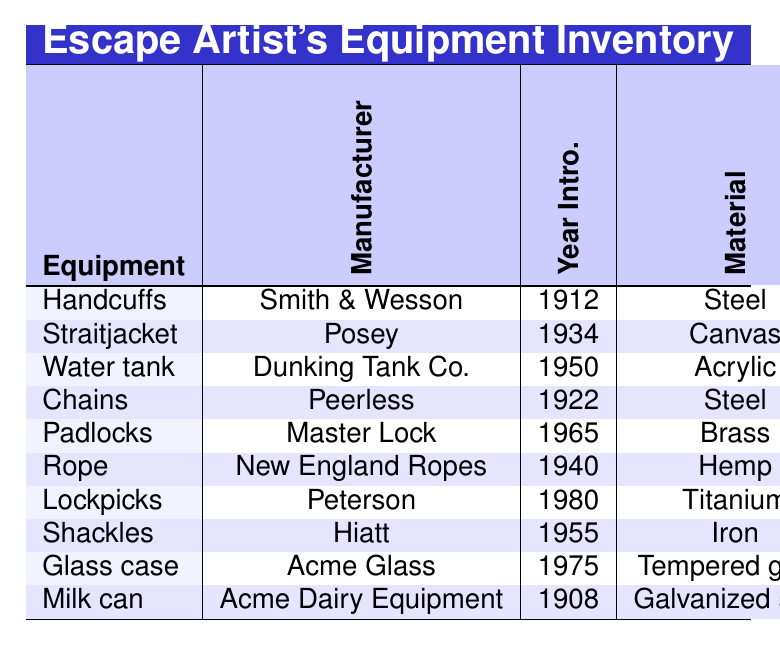What is the weight of the Water Tank? Referring to the table, the weight listed for the Water Tank is 450.0 kg.
Answer: 450.0 kg Who is the famous user of the Straitjacket? The table indicates that the famous user of the Straitjacket is Dorothy Dietrich.
Answer: Dorothy Dietrich What is the maintenance cost per year for the Handcuffs? The table shows that the maintenance cost per year for the Handcuffs is $50.
Answer: $50 Which escape equipment has the highest difficulty rating? The highest difficulty rating in the table is 10, corresponding to the Water Tank.
Answer: Water Tank What is the average lifespan of the equipment listed in the table? Adding up all lifespans: 10 + 5 + 15 + 8 + 3 + 2 + 1 + 7 + 20 + 12 = 83. Then, dividing by the number of equipment (10), the average lifespan is 83 / 10 = 8.3 years.
Answer: 8.3 years How many seconds does it take to escape from the Milk Can? According to the table, the escape time for the Milk Can is 240 seconds.
Answer: 240 seconds Is the average maintenance cost for all equipment greater than $100? The maintenance costs are $50, $100, $2000, $75, $25, $30, $15, $60, $500, and $200. The average is (50 + 100 + 2000 + 75 + 25 + 30 + 15 + 60 + 500 + 200) / 10 = 2910 / 10 = 291. Thus, it is greater than $100.
Answer: Yes What is the total weight of all the equipment combined? Summing the weights: 0.5 + 2.3 + 450.0 + 3.2 + 0.2 + 1.5 + 0.1 + 1.8 + 120.0 + 25.0 = 604.1 kg.
Answer: 604.1 kg Which equipment is made of acrylic? The table indicates that the Water Tank is made of acrylic.
Answer: Water Tank How many pieces of equipment have a weight of less than 2 kg? Looking at the table, the Handcuffs (0.5 kg), Padlocks (0.2 kg), and Lockpicks (0.1 kg) are less than 2 kg, making a total of 3 pieces.
Answer: 3 pieces 